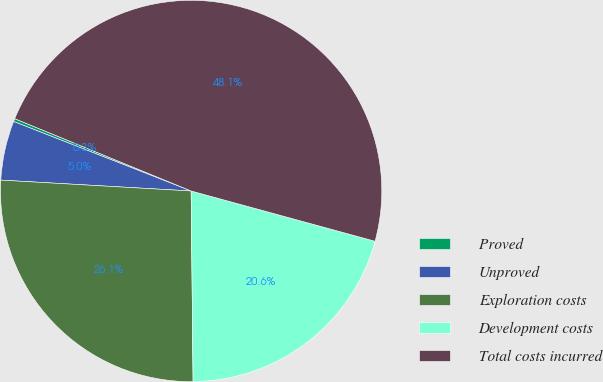<chart> <loc_0><loc_0><loc_500><loc_500><pie_chart><fcel>Proved<fcel>Unproved<fcel>Exploration costs<fcel>Development costs<fcel>Total costs incurred<nl><fcel>0.25%<fcel>5.03%<fcel>26.07%<fcel>20.59%<fcel>48.05%<nl></chart> 